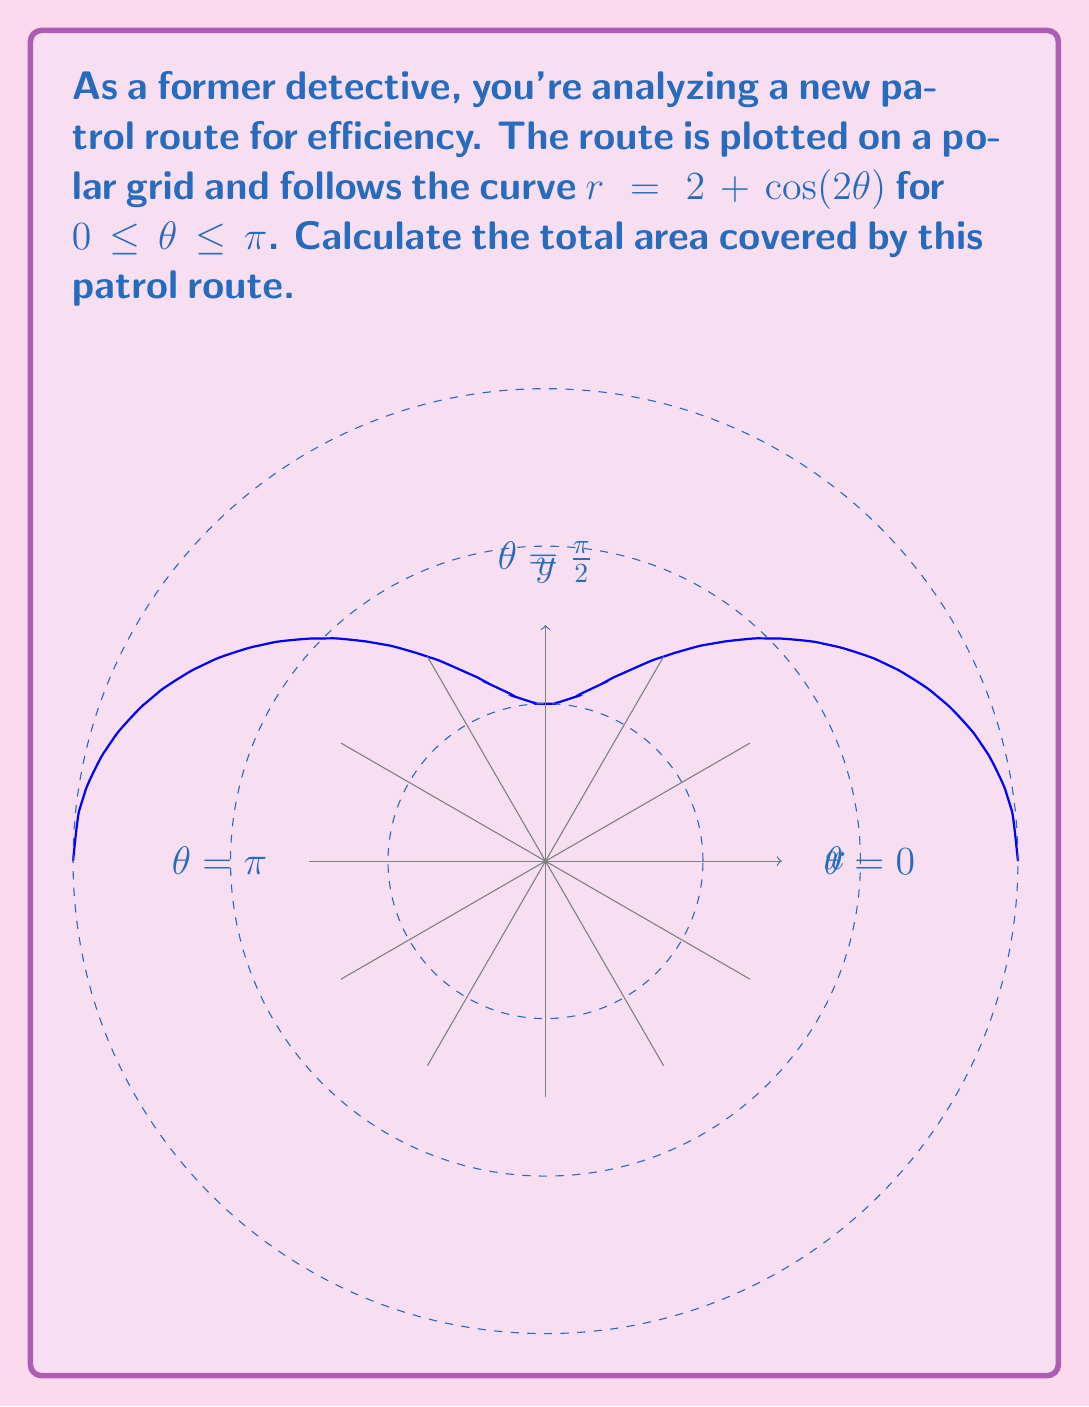Can you answer this question? To calculate the area covered by the patrol route, we need to use the formula for area in polar coordinates:

$$ A = \frac{1}{2} \int_{a}^{b} r^2(\theta) d\theta $$

Where $r(\theta) = 2 + \cos(2\theta)$ and the limits are from $0$ to $\pi$.

Step 1: Set up the integral
$$ A = \frac{1}{2} \int_{0}^{\pi} (2 + \cos(2\theta))^2 d\theta $$

Step 2: Expand the squared term
$$ A = \frac{1}{2} \int_{0}^{\pi} (4 + 4\cos(2\theta) + \cos^2(2\theta)) d\theta $$

Step 3: Use the identity $\cos^2(x) = \frac{1}{2}(1 + \cos(2x))$
$$ A = \frac{1}{2} \int_{0}^{\pi} (4 + 4\cos(2\theta) + \frac{1}{2}(1 + \cos(4\theta))) d\theta $$

Step 4: Simplify
$$ A = \frac{1}{2} \int_{0}^{\pi} (\frac{9}{2} + 4\cos(2\theta) + \frac{1}{2}\cos(4\theta)) d\theta $$

Step 5: Integrate each term
$$ A = \frac{1}{2} [\frac{9}{2}\theta + 2\sin(2\theta) + \frac{1}{8}\sin(4\theta)]_{0}^{\pi} $$

Step 6: Evaluate the definite integral
$$ A = \frac{1}{2} [(\frac{9\pi}{2} + 0 + 0) - (0 + 0 + 0)] = \frac{9\pi}{4} $$

Therefore, the total area covered by the patrol route is $\frac{9\pi}{4}$ square units.
Answer: $\frac{9\pi}{4}$ square units 